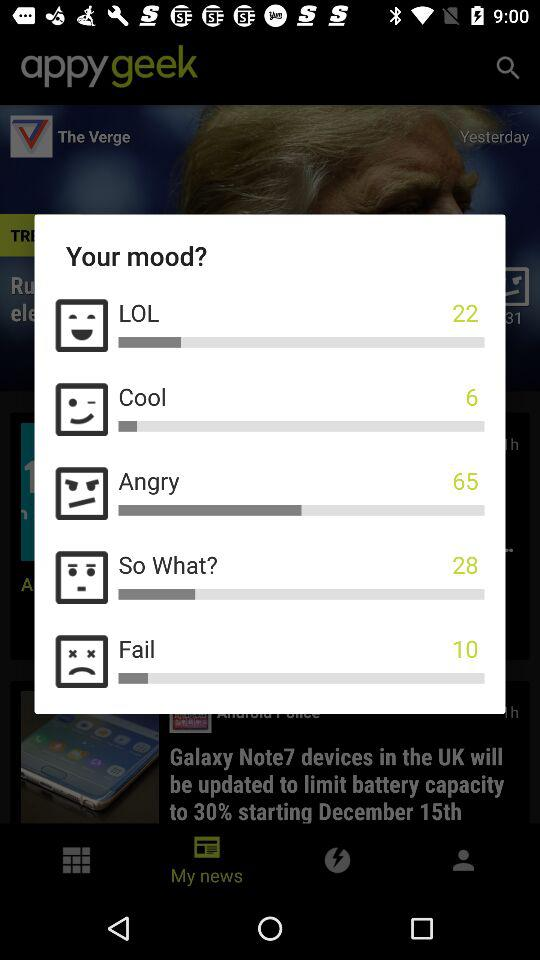How many people have voted for the angry mood? The number of people who have voted for the angry mood is 65. 